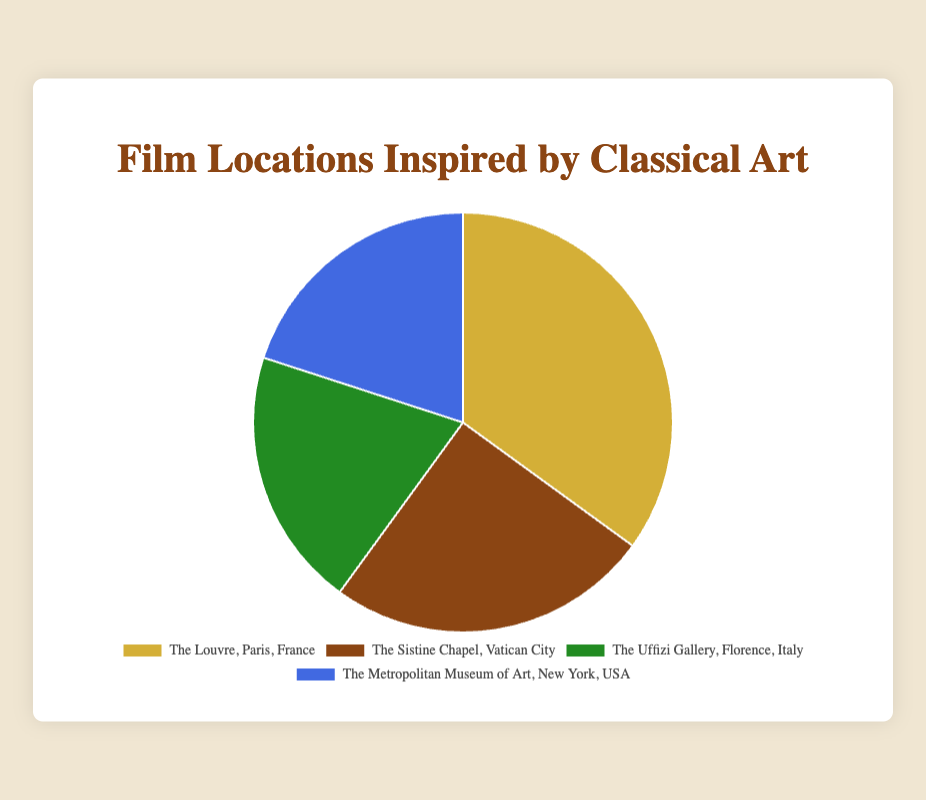What's the total percentage of film locations inspired by classical art situated outside Europe? To find the total percentage of film locations outside Europe, add up the percentages of The Metropolitan Museum of Art, New York, USA, which is the only location listed outside Europe: \(20\%\).
Answer: 20% Which location has the highest percentage of film locations and by how much does it exceed the least popular location? The Louvre, Paris, France has the highest percentage at 35%. The least popular locations are The Uffizi Gallery, Florence, Italy, and The Metropolitan Museum of Art, New York, USA, each at 20%. The difference between 35% and 20% is \(35\% - 20\% = 15\%\).
Answer: The Louvre exceeds by 15% What is the combined percentage of film locations inspired by The Uffizi Gallery and The Metropolitan Museum of Art? Sum the percentages of The Uffizi Gallery, Florence, Italy (20%) and The Metropolitan Museum of Art, New York, USA (20%): \(20\% + 20\% = 40\%\).
Answer: 40% How does the percentage for The Sistine Chapel compare to the average percentage of all locations presented in the figure? First, find the average percentage: \(\frac{35\% + 25\% + 20\% + 20\%}{4} = 25\%\). The Sistine Chapel is 25%, which is equal to the average percentage.
Answer: Equal Which inspired location uses the color green in the pie chart? The pie chart uses the color green for The Uffizi Gallery, Florence, Italy according to the visual data provided.
Answer: The Uffizi Gallery How much more popular is The Louvre than The Sistine Chapel? The Louvre is at 35% while The Sistine Chapel is at 25%. The difference is \(35\% - 25\% = 10\%\).
Answer: 10% What percentage do The Uffizi Gallery and The Sistine Chapel contribute together to the total film locations? Add the percentages of The Uffizi Gallery (20%) and The Sistine Chapel (25%): \(20\% + 25\% = 45\%\).
Answer: 45% If a new film location is added inspired by classical art with 10% more popularity than The Metropolitan Museum of Art, what would its percentage be? The Metropolitan Museum of Art has 20%. Adding 10% more popularity: \(20\% + 10\% = 30\%\).
Answer: 30% What are the three most popular film locations inspired by classical art? The three most popular locations based on the percentages are The Louvre (35%), The Sistine Chapel (25%), and The Uffizi Gallery (20%) along with The Metropolitan Museum of Art (20%). However, The Louvre, The Sistine Chapel, and The Uffizi Gallery could be listed first for variety.
Answer: The Louvre, The Sistine Chapel, The Uffizi Gallery 